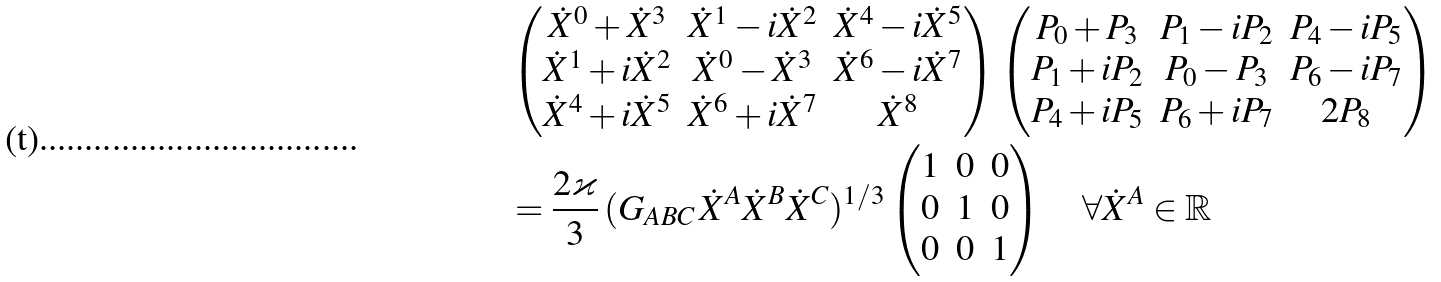<formula> <loc_0><loc_0><loc_500><loc_500>& \begin{pmatrix} \dot { X } ^ { 0 } + \dot { X } ^ { 3 } & \dot { X } ^ { 1 } - i \dot { X } ^ { 2 } & \dot { X } ^ { 4 } - i \dot { X } ^ { 5 } \\ \dot { X } ^ { 1 } + i \dot { X } ^ { 2 } & \dot { X } ^ { 0 } - \dot { X } ^ { 3 } & \dot { X } ^ { 6 } - i \dot { X } ^ { 7 } \\ \dot { X } ^ { 4 } + i \dot { X } ^ { 5 } & \dot { X } ^ { 6 } + i \dot { X } ^ { 7 } & \dot { X } ^ { 8 } \end{pmatrix} \begin{pmatrix} P _ { 0 } + P _ { 3 } & P _ { 1 } - i P _ { 2 } & P _ { 4 } - i P _ { 5 } \\ P _ { 1 } + i P _ { 2 } & P _ { 0 } - P _ { 3 } & P _ { 6 } - i P _ { 7 } \\ P _ { 4 } + i P _ { 5 } & P _ { 6 } + i P _ { 7 } & 2 P _ { 8 } \end{pmatrix} \\ & = \frac { 2 \varkappa } { 3 } \, ( G _ { A B C } \, \dot { X } ^ { A } \dot { X } ^ { B } \dot { X } ^ { C } ) ^ { 1 / 3 } \begin{pmatrix} 1 & 0 & 0 \\ 0 & 1 & 0 \\ 0 & 0 & 1 \\ \end{pmatrix} \quad \forall \dot { X } ^ { A } \in \mathbb { R }</formula> 